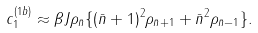<formula> <loc_0><loc_0><loc_500><loc_500>c _ { 1 } ^ { ( 1 b ) } \approx \beta J \rho _ { \bar { n } } \{ ( \bar { n } + 1 ) ^ { 2 } \rho _ { \bar { n } + 1 } + \bar { n } ^ { 2 } \rho _ { \bar { n } - 1 } \} .</formula> 